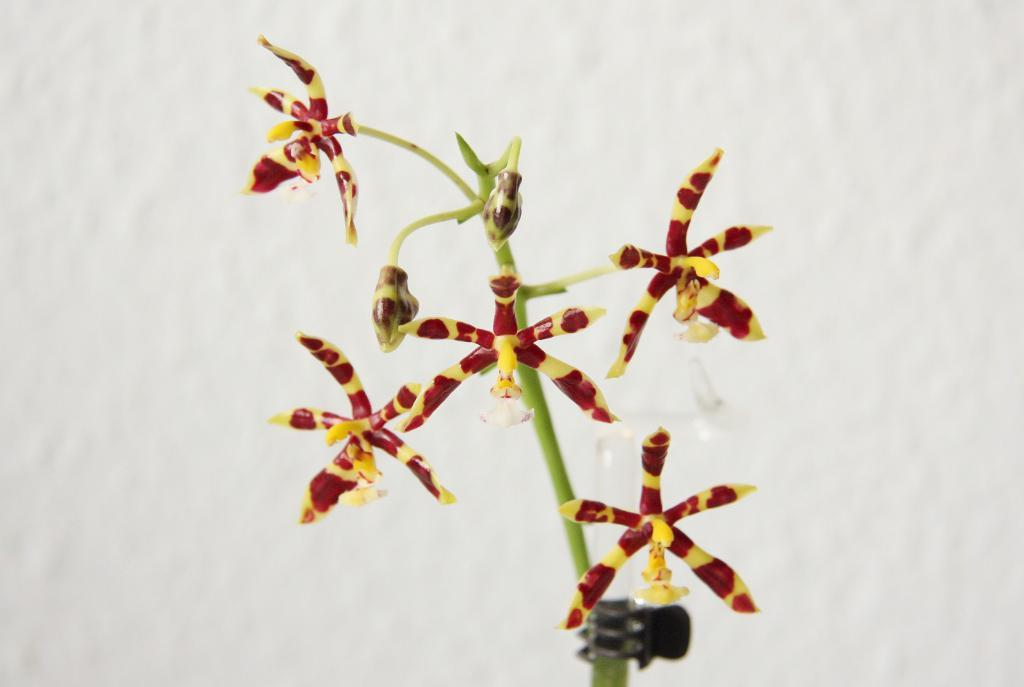What is the main subject of the image? There is a plant in the center of the image. Can you describe the plant in the image? The plant is the main focus of the image, but no specific details about its appearance are provided. What might be the purpose of the image? The purpose of the image is not explicitly stated, but it could be to showcase the plant or to use it as a decorative element. How many books are stacked on the plant in the image? There are no books present in the image; it only features a plant. 